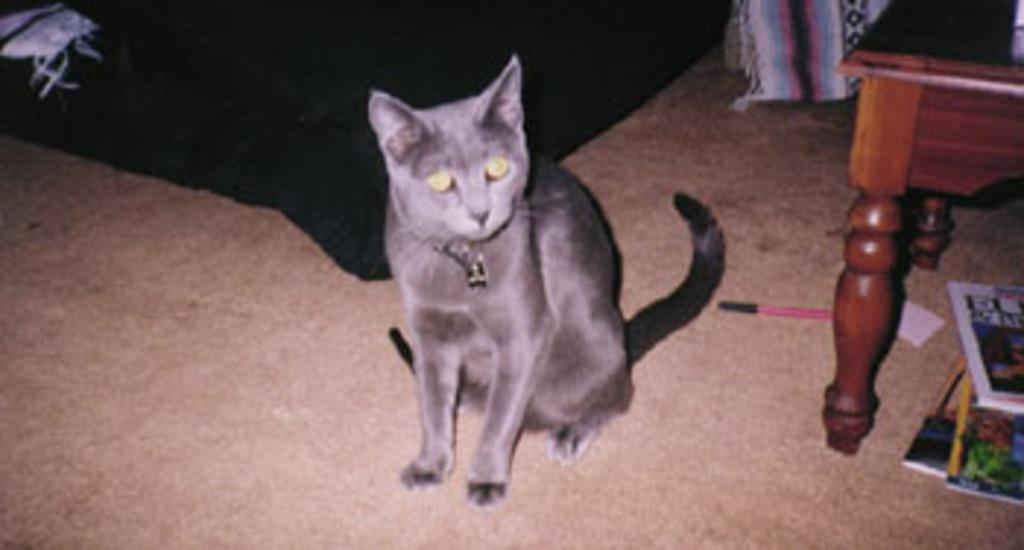What type of animal is in the image? There is a cat in the image. Where is the cat sitting? The cat is sitting on a brown carpet. What other objects can be seen in the image? There is a table, a pen, and a book in the image. Where are the pen and book located? The pen and book are on the carpet. What color is the cloth in the image? The cloth in the image is black. How long is the trail that the cat is hiking in the image? There is no trail present in the image, as it features a cat sitting on a brown carpet. What time of day is the trip taking place in the image? There is no trip depicted in the image, so it is not possible to determine the time of day. 